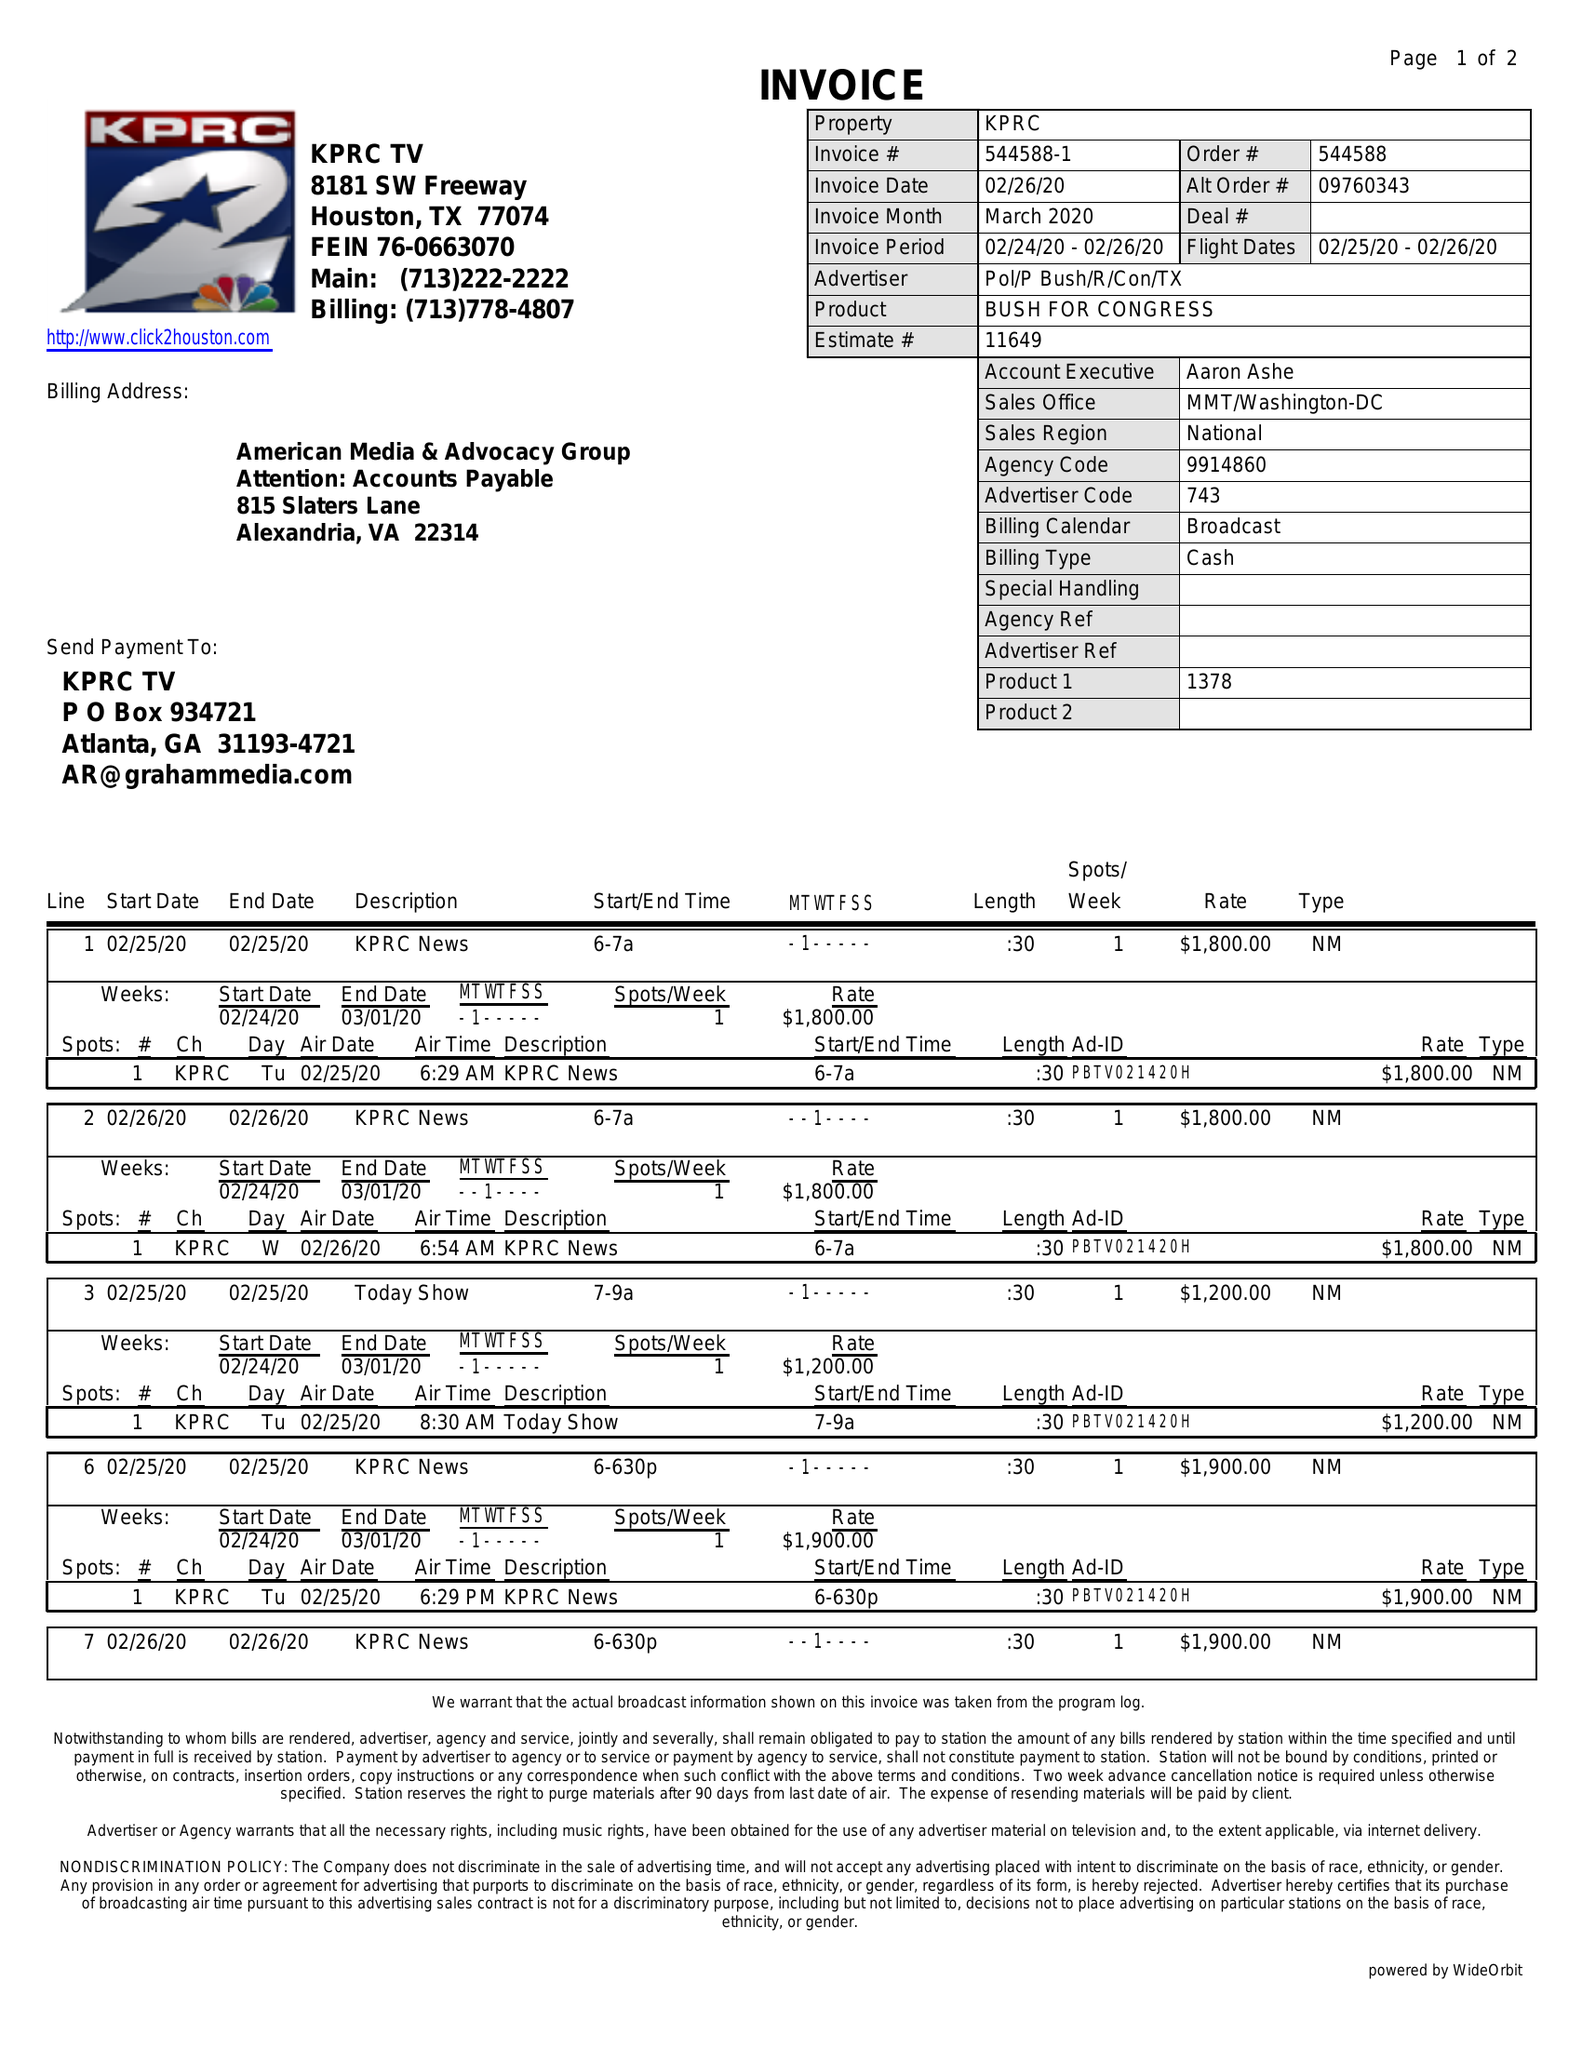What is the value for the advertiser?
Answer the question using a single word or phrase. POL/PBUSH/R/CON/TX 